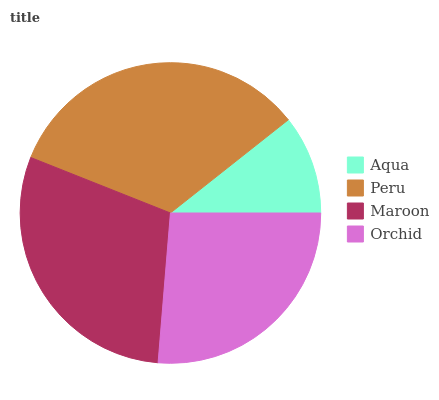Is Aqua the minimum?
Answer yes or no. Yes. Is Peru the maximum?
Answer yes or no. Yes. Is Maroon the minimum?
Answer yes or no. No. Is Maroon the maximum?
Answer yes or no. No. Is Peru greater than Maroon?
Answer yes or no. Yes. Is Maroon less than Peru?
Answer yes or no. Yes. Is Maroon greater than Peru?
Answer yes or no. No. Is Peru less than Maroon?
Answer yes or no. No. Is Maroon the high median?
Answer yes or no. Yes. Is Orchid the low median?
Answer yes or no. Yes. Is Peru the high median?
Answer yes or no. No. Is Maroon the low median?
Answer yes or no. No. 